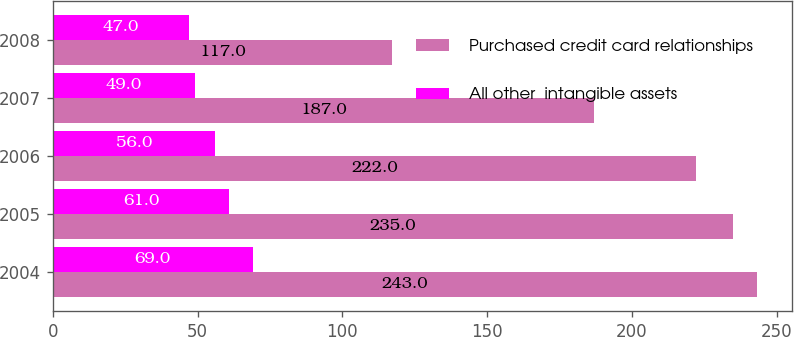Convert chart. <chart><loc_0><loc_0><loc_500><loc_500><stacked_bar_chart><ecel><fcel>2004<fcel>2005<fcel>2006<fcel>2007<fcel>2008<nl><fcel>Purchased credit card relationships<fcel>243<fcel>235<fcel>222<fcel>187<fcel>117<nl><fcel>All other  intangible assets<fcel>69<fcel>61<fcel>56<fcel>49<fcel>47<nl></chart> 